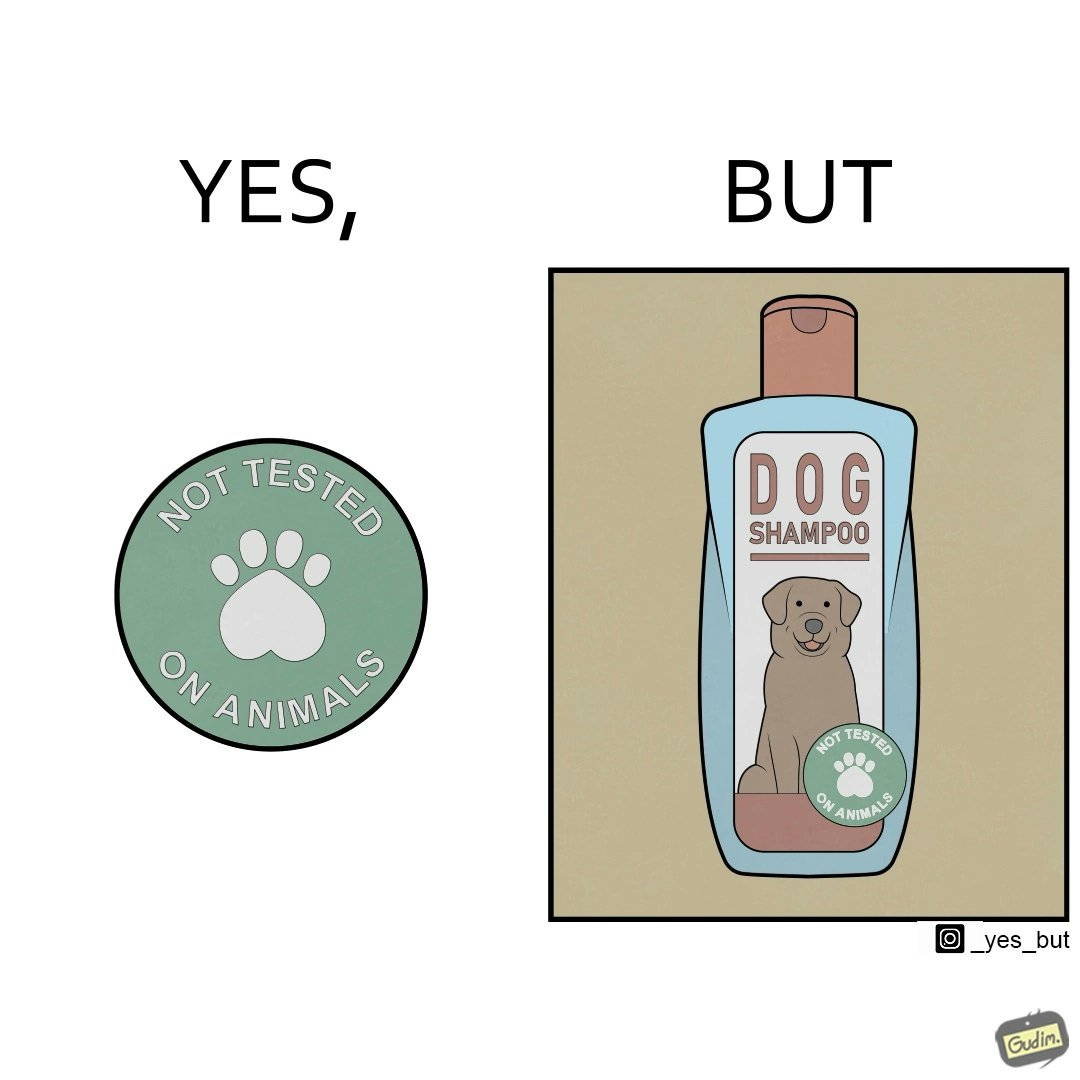What does this image depict? The images are ironic since a dog shampoo bottle has a sticker indicating that it has not been tested on animals and hence might not be safe for animal use. It is amusing that a product designed to be used by animals is not tested on animals for their safety 